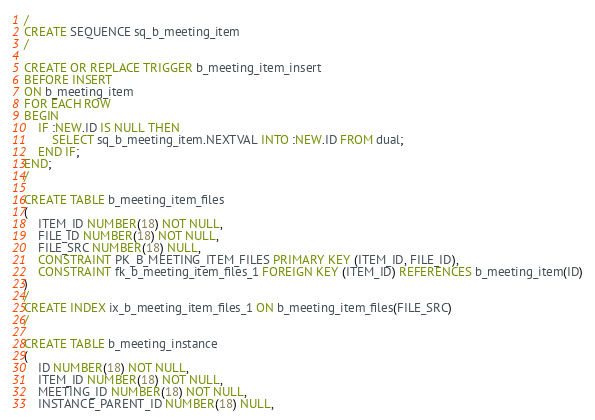<code> <loc_0><loc_0><loc_500><loc_500><_SQL_>/
CREATE SEQUENCE sq_b_meeting_item
/

CREATE OR REPLACE TRIGGER b_meeting_item_insert
BEFORE INSERT
ON b_meeting_item
FOR EACH ROW
BEGIN
	IF :NEW.ID IS NULL THEN
 		SELECT sq_b_meeting_item.NEXTVAL INTO :NEW.ID FROM dual;
	END IF;
END;
/

CREATE TABLE b_meeting_item_files
(
	ITEM_ID NUMBER(18) NOT NULL,
	FILE_ID NUMBER(18) NOT NULL,
	FILE_SRC NUMBER(18) NULL,
	CONSTRAINT PK_B_MEETING_ITEM_FILES PRIMARY KEY (ITEM_ID, FILE_ID),
	CONSTRAINT fk_b_meeting_item_files_1 FOREIGN KEY (ITEM_ID) REFERENCES b_meeting_item(ID)
)
/
CREATE INDEX ix_b_meeting_item_files_1 ON b_meeting_item_files(FILE_SRC)
/

CREATE TABLE b_meeting_instance
(
	ID NUMBER(18) NOT NULL,
	ITEM_ID NUMBER(18) NOT NULL,
	MEETING_ID NUMBER(18) NOT NULL,
	INSTANCE_PARENT_ID NUMBER(18) NULL,</code> 